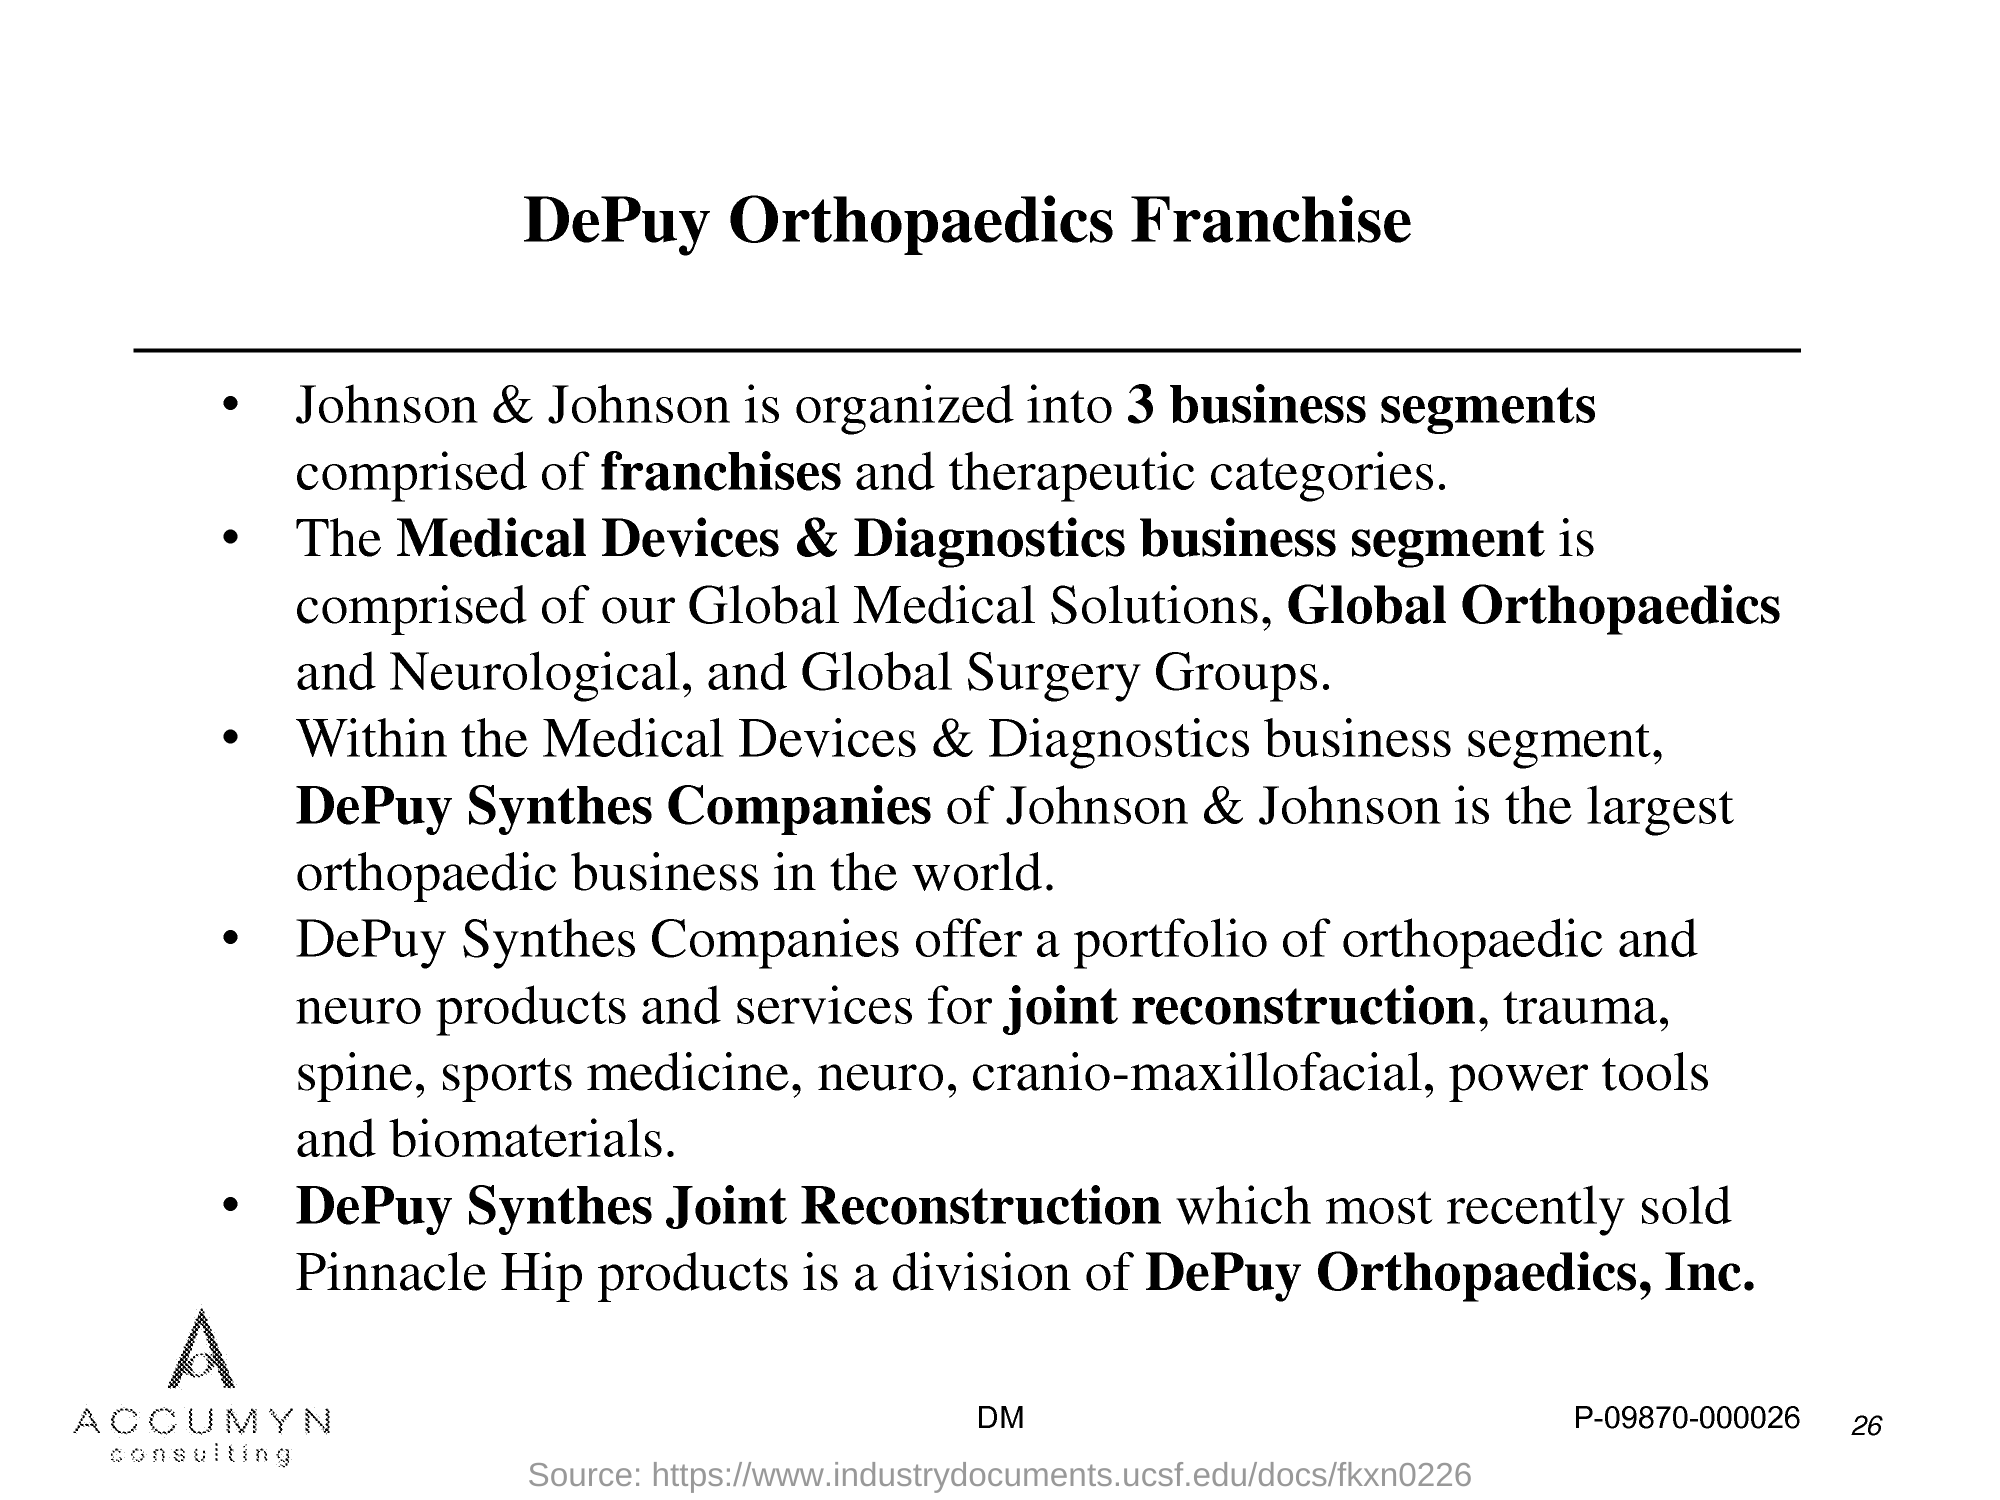What are 3 business segments of Johnson &Johnson comprised of?
Your answer should be compact. Franchises and therapeutic categories. Which is the largest orthopaedic business in the world?
Give a very brief answer. DePuy Synthes Companies of Johnson  & Johnson. Which company offers portfolio of orthopaedic and neuro products?
Offer a very short reply. DePuy Synthes Companies. Which is the most recently sold Pinnacle Hip products?
Offer a very short reply. DePuy Synthes Joint Reconstruction. Which company provides services for joint reconstruction?
Your response must be concise. DePuy Synthes Companies. Which company provides services for cranio-maxillofacial?
Keep it short and to the point. DePuy Synthes Companies. 